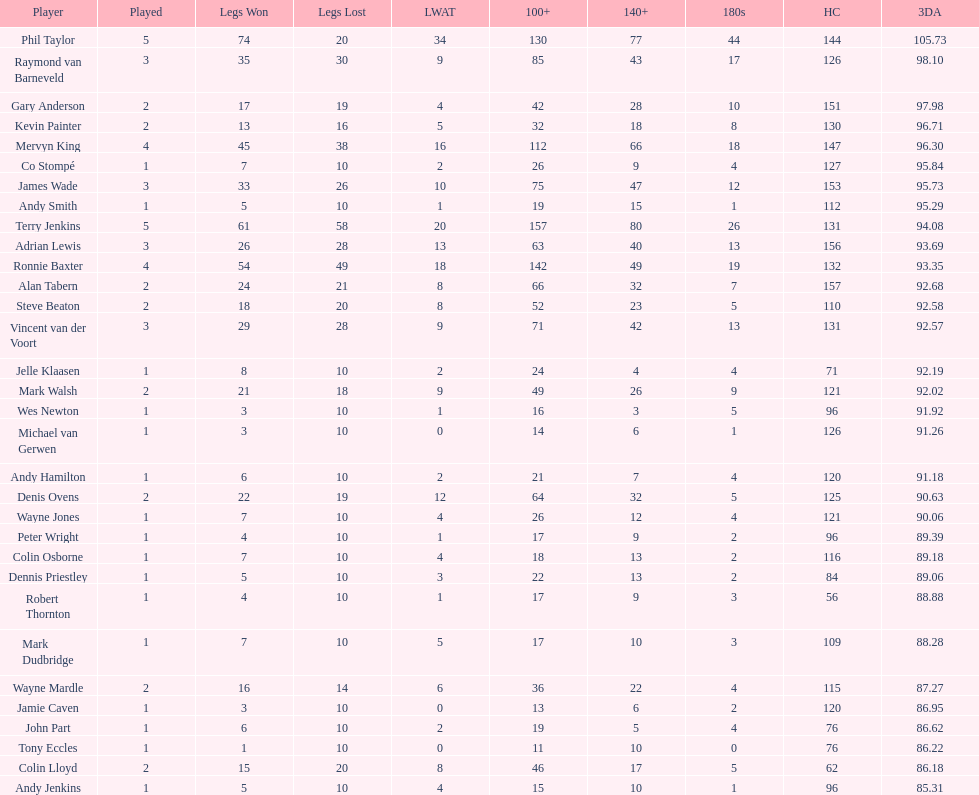List each of the players with a high checkout of 131. Terry Jenkins, Vincent van der Voort. 